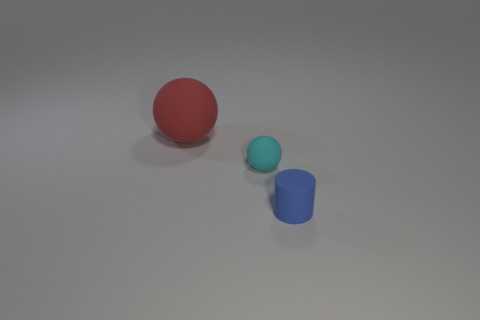What is the lighting situation in this scene? The lighting in the image is soft and diffused, with no harsh shadows indicating a single, strong light source. It suggests an evenly lit environment, possibly through indirect lighting or a softbox used in photography to create such balanced illumination.  What time of day does this lighting resemble? The lighting doesn't specifically resemble natural daylight as one might experience at any particular time of day, since it lacks directional qualities and the color temperature that you'd expect from sunlight. Instead, it's more reminiscent of studio lighting used in photography or rendering software typically used to create product visuals. 